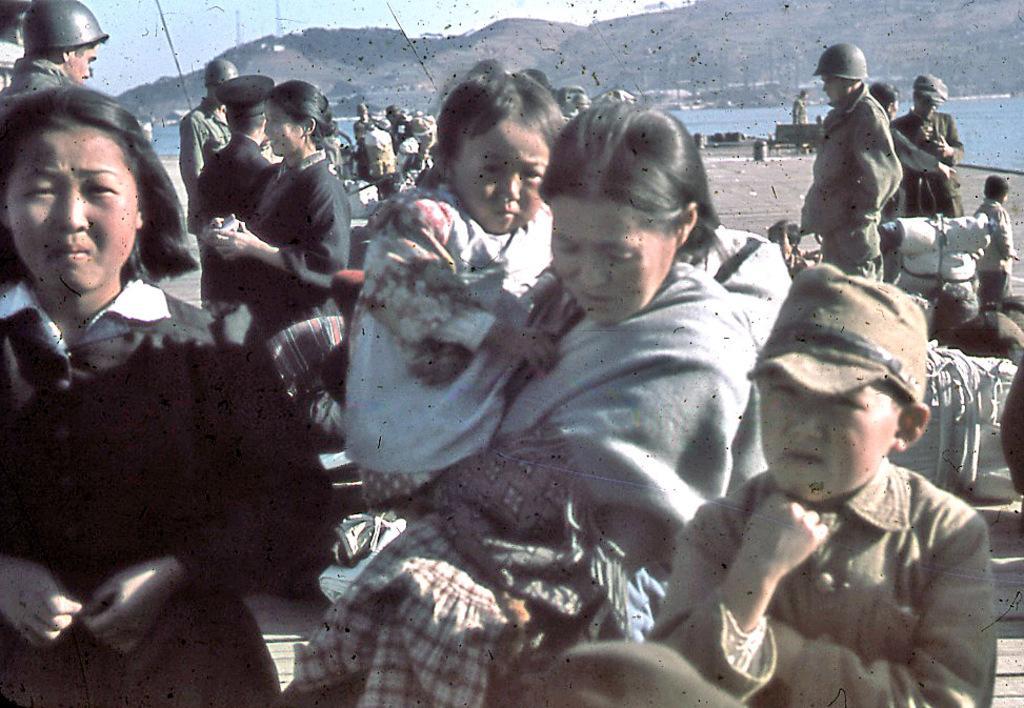Could you give a brief overview of what you see in this image? In this picture we can see group of people. This is water. In the background there is a mountain and sky. 